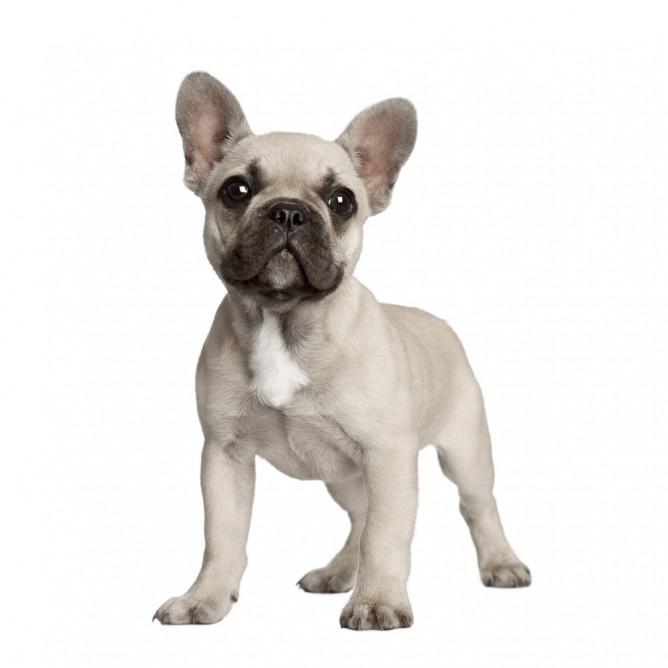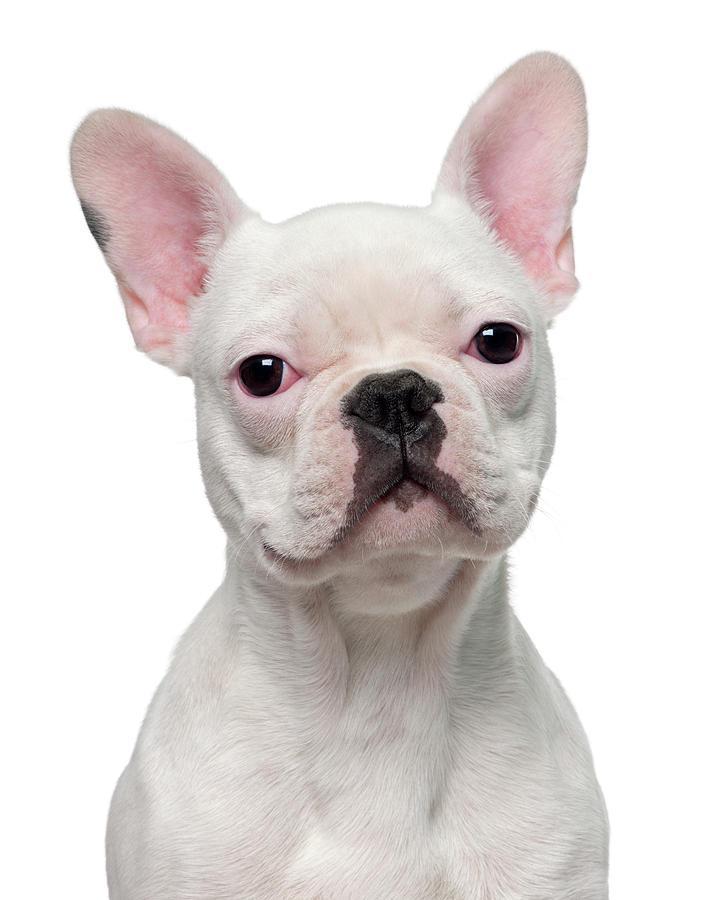The first image is the image on the left, the second image is the image on the right. For the images shown, is this caption "One dog is standing." true? Answer yes or no. Yes. The first image is the image on the left, the second image is the image on the right. For the images shown, is this caption "One image shows a french bulldog standing on all fours, and the other image includes a white bulldog looking straight at the camera." true? Answer yes or no. Yes. 